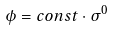<formula> <loc_0><loc_0><loc_500><loc_500>\phi = c o n s t \cdot \sigma ^ { 0 }</formula> 